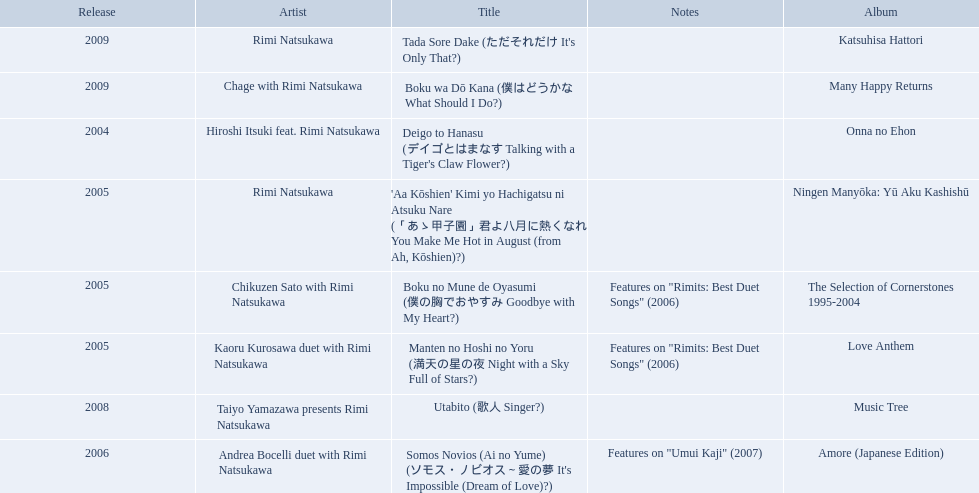When was onna no ehon released? 2004. When was the selection of cornerstones 1995-2004 released? 2005. What was released in 2008? Music Tree. 